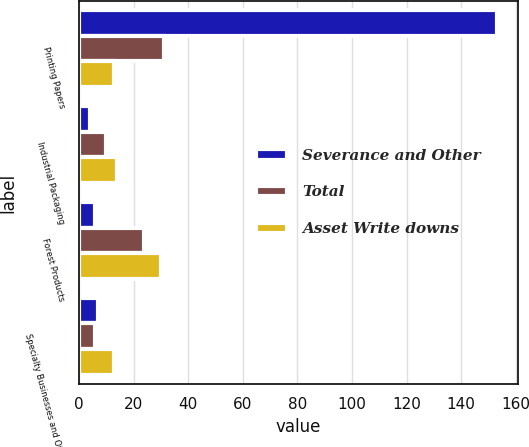<chart> <loc_0><loc_0><loc_500><loc_500><stacked_bar_chart><ecel><fcel>Printing Papers<fcel>Industrial Packaging<fcel>Forest Products<fcel>Specialty Businesses and Other<nl><fcel>Severance and Other<fcel>153<fcel>4<fcel>6<fcel>7<nl><fcel>Total<fcel>31<fcel>10<fcel>24<fcel>6<nl><fcel>Asset Write downs<fcel>13<fcel>14<fcel>30<fcel>13<nl></chart> 